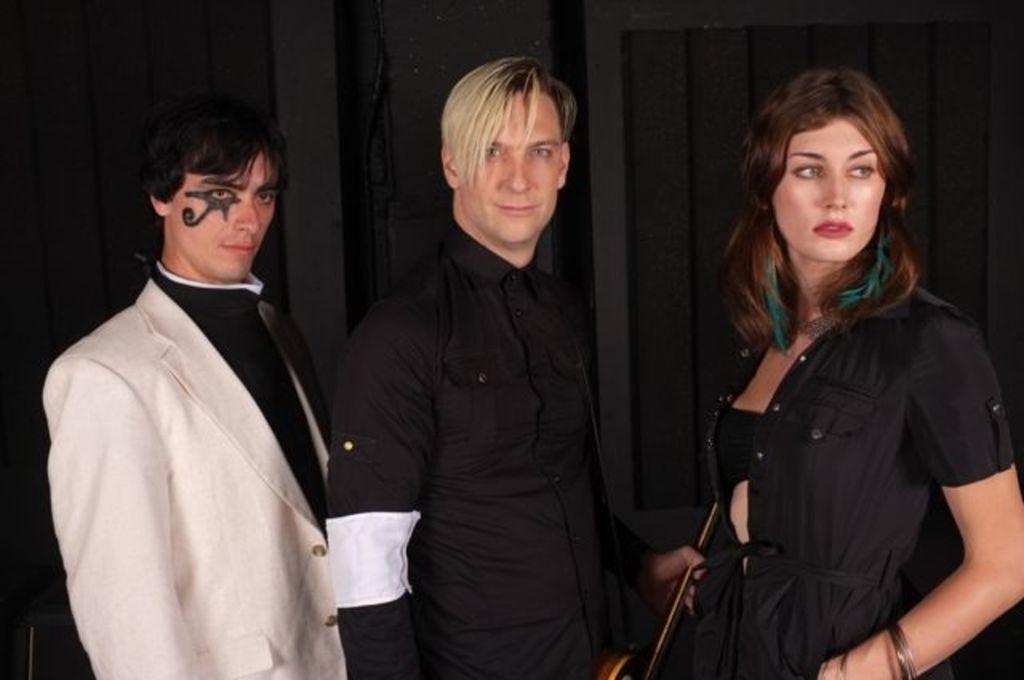Can you describe this image briefly? In this image we can see three people standing and a person in the middle is holding an object looks like a guitar and there is a dark background. 